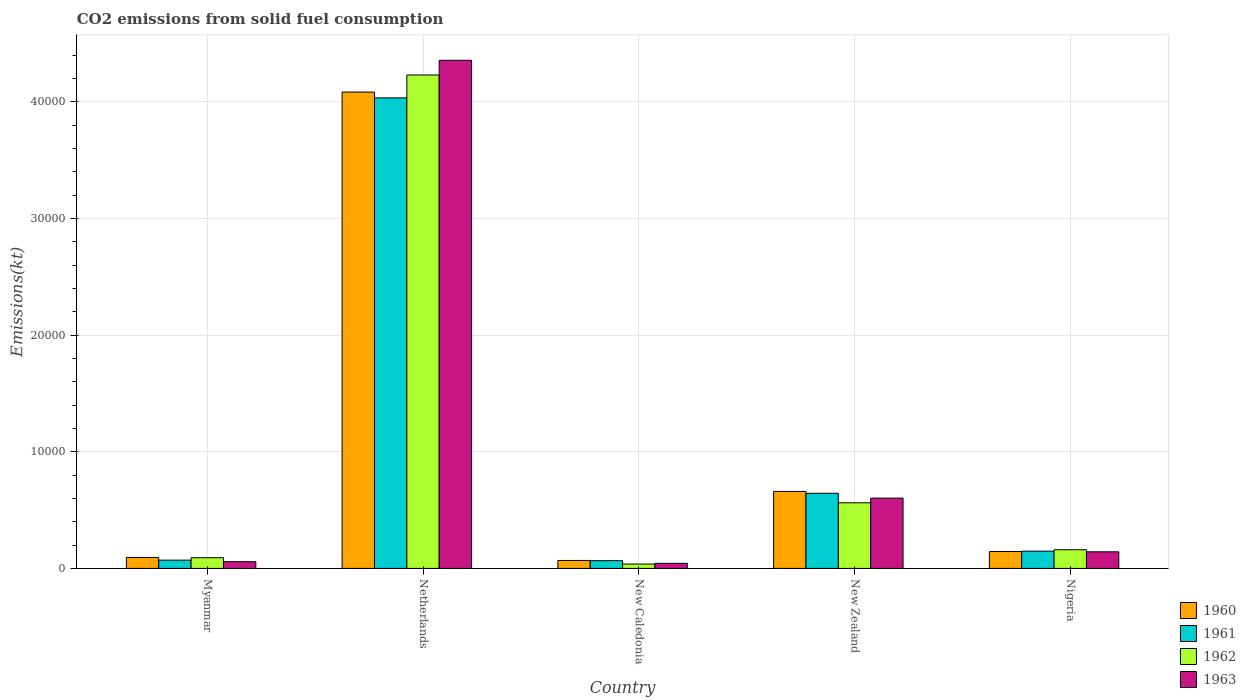How many bars are there on the 1st tick from the left?
Provide a short and direct response. 4. How many bars are there on the 4th tick from the right?
Your answer should be very brief. 4. What is the label of the 5th group of bars from the left?
Provide a short and direct response. Nigeria. In how many cases, is the number of bars for a given country not equal to the number of legend labels?
Offer a very short reply. 0. What is the amount of CO2 emitted in 1963 in Nigeria?
Give a very brief answer. 1422.8. Across all countries, what is the maximum amount of CO2 emitted in 1961?
Ensure brevity in your answer.  4.03e+04. Across all countries, what is the minimum amount of CO2 emitted in 1960?
Offer a very short reply. 682.06. In which country was the amount of CO2 emitted in 1962 maximum?
Provide a succinct answer. Netherlands. In which country was the amount of CO2 emitted in 1962 minimum?
Provide a succinct answer. New Caledonia. What is the total amount of CO2 emitted in 1960 in the graph?
Offer a terse response. 5.05e+04. What is the difference between the amount of CO2 emitted in 1962 in Myanmar and that in Nigeria?
Your answer should be compact. -682.06. What is the difference between the amount of CO2 emitted in 1960 in Netherlands and the amount of CO2 emitted in 1961 in Myanmar?
Your answer should be compact. 4.01e+04. What is the average amount of CO2 emitted in 1963 per country?
Offer a very short reply. 1.04e+04. What is the difference between the amount of CO2 emitted of/in 1960 and amount of CO2 emitted of/in 1963 in Myanmar?
Your answer should be compact. 363.03. In how many countries, is the amount of CO2 emitted in 1960 greater than 28000 kt?
Your answer should be very brief. 1. What is the ratio of the amount of CO2 emitted in 1962 in New Caledonia to that in New Zealand?
Give a very brief answer. 0.07. What is the difference between the highest and the second highest amount of CO2 emitted in 1961?
Give a very brief answer. -3.89e+04. What is the difference between the highest and the lowest amount of CO2 emitted in 1962?
Offer a very short reply. 4.19e+04. Is the sum of the amount of CO2 emitted in 1963 in Myanmar and Netherlands greater than the maximum amount of CO2 emitted in 1962 across all countries?
Offer a terse response. Yes. What does the 1st bar from the left in Netherlands represents?
Offer a terse response. 1960. How many countries are there in the graph?
Give a very brief answer. 5. What is the difference between two consecutive major ticks on the Y-axis?
Your response must be concise. 10000. Does the graph contain any zero values?
Offer a very short reply. No. Does the graph contain grids?
Ensure brevity in your answer.  Yes. Where does the legend appear in the graph?
Keep it short and to the point. Bottom right. How are the legend labels stacked?
Your response must be concise. Vertical. What is the title of the graph?
Provide a succinct answer. CO2 emissions from solid fuel consumption. What is the label or title of the Y-axis?
Give a very brief answer. Emissions(kt). What is the Emissions(kt) of 1960 in Myanmar?
Keep it short and to the point. 938.75. What is the Emissions(kt) of 1961 in Myanmar?
Provide a short and direct response. 707.73. What is the Emissions(kt) of 1962 in Myanmar?
Keep it short and to the point. 916.75. What is the Emissions(kt) in 1963 in Myanmar?
Provide a short and direct response. 575.72. What is the Emissions(kt) in 1960 in Netherlands?
Offer a terse response. 4.08e+04. What is the Emissions(kt) of 1961 in Netherlands?
Offer a very short reply. 4.03e+04. What is the Emissions(kt) of 1962 in Netherlands?
Make the answer very short. 4.23e+04. What is the Emissions(kt) of 1963 in Netherlands?
Offer a terse response. 4.36e+04. What is the Emissions(kt) of 1960 in New Caledonia?
Your answer should be very brief. 682.06. What is the Emissions(kt) of 1961 in New Caledonia?
Offer a very short reply. 663.73. What is the Emissions(kt) in 1962 in New Caledonia?
Make the answer very short. 374.03. What is the Emissions(kt) in 1963 in New Caledonia?
Offer a terse response. 436.37. What is the Emissions(kt) in 1960 in New Zealand?
Offer a terse response. 6600.6. What is the Emissions(kt) of 1961 in New Zealand?
Make the answer very short. 6439.25. What is the Emissions(kt) in 1962 in New Zealand?
Your answer should be compact. 5625.18. What is the Emissions(kt) in 1963 in New Zealand?
Make the answer very short. 6024.88. What is the Emissions(kt) in 1960 in Nigeria?
Make the answer very short. 1448.46. What is the Emissions(kt) in 1961 in Nigeria?
Offer a terse response. 1477.8. What is the Emissions(kt) in 1962 in Nigeria?
Your answer should be very brief. 1598.81. What is the Emissions(kt) of 1963 in Nigeria?
Provide a succinct answer. 1422.8. Across all countries, what is the maximum Emissions(kt) in 1960?
Give a very brief answer. 4.08e+04. Across all countries, what is the maximum Emissions(kt) of 1961?
Keep it short and to the point. 4.03e+04. Across all countries, what is the maximum Emissions(kt) in 1962?
Your response must be concise. 4.23e+04. Across all countries, what is the maximum Emissions(kt) of 1963?
Offer a terse response. 4.36e+04. Across all countries, what is the minimum Emissions(kt) in 1960?
Give a very brief answer. 682.06. Across all countries, what is the minimum Emissions(kt) in 1961?
Your answer should be very brief. 663.73. Across all countries, what is the minimum Emissions(kt) of 1962?
Your answer should be very brief. 374.03. Across all countries, what is the minimum Emissions(kt) of 1963?
Give a very brief answer. 436.37. What is the total Emissions(kt) of 1960 in the graph?
Keep it short and to the point. 5.05e+04. What is the total Emissions(kt) of 1961 in the graph?
Your answer should be compact. 4.96e+04. What is the total Emissions(kt) in 1962 in the graph?
Provide a succinct answer. 5.08e+04. What is the total Emissions(kt) in 1963 in the graph?
Provide a succinct answer. 5.20e+04. What is the difference between the Emissions(kt) in 1960 in Myanmar and that in Netherlands?
Give a very brief answer. -3.99e+04. What is the difference between the Emissions(kt) in 1961 in Myanmar and that in Netherlands?
Provide a succinct answer. -3.96e+04. What is the difference between the Emissions(kt) of 1962 in Myanmar and that in Netherlands?
Provide a short and direct response. -4.14e+04. What is the difference between the Emissions(kt) in 1963 in Myanmar and that in Netherlands?
Offer a very short reply. -4.30e+04. What is the difference between the Emissions(kt) in 1960 in Myanmar and that in New Caledonia?
Make the answer very short. 256.69. What is the difference between the Emissions(kt) in 1961 in Myanmar and that in New Caledonia?
Ensure brevity in your answer.  44. What is the difference between the Emissions(kt) of 1962 in Myanmar and that in New Caledonia?
Offer a very short reply. 542.72. What is the difference between the Emissions(kt) in 1963 in Myanmar and that in New Caledonia?
Provide a succinct answer. 139.35. What is the difference between the Emissions(kt) in 1960 in Myanmar and that in New Zealand?
Provide a short and direct response. -5661.85. What is the difference between the Emissions(kt) of 1961 in Myanmar and that in New Zealand?
Keep it short and to the point. -5731.52. What is the difference between the Emissions(kt) in 1962 in Myanmar and that in New Zealand?
Provide a short and direct response. -4708.43. What is the difference between the Emissions(kt) of 1963 in Myanmar and that in New Zealand?
Make the answer very short. -5449.16. What is the difference between the Emissions(kt) of 1960 in Myanmar and that in Nigeria?
Your answer should be compact. -509.71. What is the difference between the Emissions(kt) in 1961 in Myanmar and that in Nigeria?
Your answer should be compact. -770.07. What is the difference between the Emissions(kt) of 1962 in Myanmar and that in Nigeria?
Make the answer very short. -682.06. What is the difference between the Emissions(kt) in 1963 in Myanmar and that in Nigeria?
Provide a succinct answer. -847.08. What is the difference between the Emissions(kt) in 1960 in Netherlands and that in New Caledonia?
Offer a very short reply. 4.01e+04. What is the difference between the Emissions(kt) of 1961 in Netherlands and that in New Caledonia?
Give a very brief answer. 3.97e+04. What is the difference between the Emissions(kt) in 1962 in Netherlands and that in New Caledonia?
Offer a very short reply. 4.19e+04. What is the difference between the Emissions(kt) in 1963 in Netherlands and that in New Caledonia?
Provide a short and direct response. 4.31e+04. What is the difference between the Emissions(kt) in 1960 in Netherlands and that in New Zealand?
Keep it short and to the point. 3.42e+04. What is the difference between the Emissions(kt) of 1961 in Netherlands and that in New Zealand?
Your answer should be very brief. 3.39e+04. What is the difference between the Emissions(kt) of 1962 in Netherlands and that in New Zealand?
Offer a very short reply. 3.67e+04. What is the difference between the Emissions(kt) in 1963 in Netherlands and that in New Zealand?
Offer a terse response. 3.75e+04. What is the difference between the Emissions(kt) of 1960 in Netherlands and that in Nigeria?
Make the answer very short. 3.94e+04. What is the difference between the Emissions(kt) in 1961 in Netherlands and that in Nigeria?
Offer a terse response. 3.89e+04. What is the difference between the Emissions(kt) in 1962 in Netherlands and that in Nigeria?
Give a very brief answer. 4.07e+04. What is the difference between the Emissions(kt) of 1963 in Netherlands and that in Nigeria?
Keep it short and to the point. 4.21e+04. What is the difference between the Emissions(kt) in 1960 in New Caledonia and that in New Zealand?
Keep it short and to the point. -5918.54. What is the difference between the Emissions(kt) of 1961 in New Caledonia and that in New Zealand?
Offer a terse response. -5775.52. What is the difference between the Emissions(kt) in 1962 in New Caledonia and that in New Zealand?
Your answer should be very brief. -5251.14. What is the difference between the Emissions(kt) of 1963 in New Caledonia and that in New Zealand?
Make the answer very short. -5588.51. What is the difference between the Emissions(kt) in 1960 in New Caledonia and that in Nigeria?
Your answer should be compact. -766.4. What is the difference between the Emissions(kt) of 1961 in New Caledonia and that in Nigeria?
Ensure brevity in your answer.  -814.07. What is the difference between the Emissions(kt) of 1962 in New Caledonia and that in Nigeria?
Provide a succinct answer. -1224.78. What is the difference between the Emissions(kt) in 1963 in New Caledonia and that in Nigeria?
Keep it short and to the point. -986.42. What is the difference between the Emissions(kt) in 1960 in New Zealand and that in Nigeria?
Provide a succinct answer. 5152.14. What is the difference between the Emissions(kt) of 1961 in New Zealand and that in Nigeria?
Your answer should be very brief. 4961.45. What is the difference between the Emissions(kt) of 1962 in New Zealand and that in Nigeria?
Your response must be concise. 4026.37. What is the difference between the Emissions(kt) of 1963 in New Zealand and that in Nigeria?
Your answer should be compact. 4602.09. What is the difference between the Emissions(kt) in 1960 in Myanmar and the Emissions(kt) in 1961 in Netherlands?
Your response must be concise. -3.94e+04. What is the difference between the Emissions(kt) of 1960 in Myanmar and the Emissions(kt) of 1962 in Netherlands?
Your response must be concise. -4.14e+04. What is the difference between the Emissions(kt) in 1960 in Myanmar and the Emissions(kt) in 1963 in Netherlands?
Your answer should be very brief. -4.26e+04. What is the difference between the Emissions(kt) of 1961 in Myanmar and the Emissions(kt) of 1962 in Netherlands?
Your response must be concise. -4.16e+04. What is the difference between the Emissions(kt) of 1961 in Myanmar and the Emissions(kt) of 1963 in Netherlands?
Give a very brief answer. -4.28e+04. What is the difference between the Emissions(kt) in 1962 in Myanmar and the Emissions(kt) in 1963 in Netherlands?
Keep it short and to the point. -4.26e+04. What is the difference between the Emissions(kt) in 1960 in Myanmar and the Emissions(kt) in 1961 in New Caledonia?
Your answer should be very brief. 275.02. What is the difference between the Emissions(kt) in 1960 in Myanmar and the Emissions(kt) in 1962 in New Caledonia?
Provide a succinct answer. 564.72. What is the difference between the Emissions(kt) in 1960 in Myanmar and the Emissions(kt) in 1963 in New Caledonia?
Your answer should be compact. 502.38. What is the difference between the Emissions(kt) in 1961 in Myanmar and the Emissions(kt) in 1962 in New Caledonia?
Offer a terse response. 333.7. What is the difference between the Emissions(kt) in 1961 in Myanmar and the Emissions(kt) in 1963 in New Caledonia?
Give a very brief answer. 271.36. What is the difference between the Emissions(kt) in 1962 in Myanmar and the Emissions(kt) in 1963 in New Caledonia?
Provide a short and direct response. 480.38. What is the difference between the Emissions(kt) of 1960 in Myanmar and the Emissions(kt) of 1961 in New Zealand?
Give a very brief answer. -5500.5. What is the difference between the Emissions(kt) in 1960 in Myanmar and the Emissions(kt) in 1962 in New Zealand?
Offer a very short reply. -4686.43. What is the difference between the Emissions(kt) of 1960 in Myanmar and the Emissions(kt) of 1963 in New Zealand?
Make the answer very short. -5086.13. What is the difference between the Emissions(kt) of 1961 in Myanmar and the Emissions(kt) of 1962 in New Zealand?
Keep it short and to the point. -4917.45. What is the difference between the Emissions(kt) of 1961 in Myanmar and the Emissions(kt) of 1963 in New Zealand?
Make the answer very short. -5317.15. What is the difference between the Emissions(kt) of 1962 in Myanmar and the Emissions(kt) of 1963 in New Zealand?
Ensure brevity in your answer.  -5108.13. What is the difference between the Emissions(kt) of 1960 in Myanmar and the Emissions(kt) of 1961 in Nigeria?
Offer a very short reply. -539.05. What is the difference between the Emissions(kt) of 1960 in Myanmar and the Emissions(kt) of 1962 in Nigeria?
Offer a terse response. -660.06. What is the difference between the Emissions(kt) of 1960 in Myanmar and the Emissions(kt) of 1963 in Nigeria?
Your response must be concise. -484.04. What is the difference between the Emissions(kt) of 1961 in Myanmar and the Emissions(kt) of 1962 in Nigeria?
Your response must be concise. -891.08. What is the difference between the Emissions(kt) in 1961 in Myanmar and the Emissions(kt) in 1963 in Nigeria?
Ensure brevity in your answer.  -715.07. What is the difference between the Emissions(kt) in 1962 in Myanmar and the Emissions(kt) in 1963 in Nigeria?
Your answer should be very brief. -506.05. What is the difference between the Emissions(kt) of 1960 in Netherlands and the Emissions(kt) of 1961 in New Caledonia?
Your response must be concise. 4.02e+04. What is the difference between the Emissions(kt) of 1960 in Netherlands and the Emissions(kt) of 1962 in New Caledonia?
Keep it short and to the point. 4.05e+04. What is the difference between the Emissions(kt) of 1960 in Netherlands and the Emissions(kt) of 1963 in New Caledonia?
Give a very brief answer. 4.04e+04. What is the difference between the Emissions(kt) in 1961 in Netherlands and the Emissions(kt) in 1962 in New Caledonia?
Provide a succinct answer. 4.00e+04. What is the difference between the Emissions(kt) of 1961 in Netherlands and the Emissions(kt) of 1963 in New Caledonia?
Keep it short and to the point. 3.99e+04. What is the difference between the Emissions(kt) of 1962 in Netherlands and the Emissions(kt) of 1963 in New Caledonia?
Your answer should be very brief. 4.19e+04. What is the difference between the Emissions(kt) of 1960 in Netherlands and the Emissions(kt) of 1961 in New Zealand?
Give a very brief answer. 3.44e+04. What is the difference between the Emissions(kt) in 1960 in Netherlands and the Emissions(kt) in 1962 in New Zealand?
Your response must be concise. 3.52e+04. What is the difference between the Emissions(kt) of 1960 in Netherlands and the Emissions(kt) of 1963 in New Zealand?
Ensure brevity in your answer.  3.48e+04. What is the difference between the Emissions(kt) of 1961 in Netherlands and the Emissions(kt) of 1962 in New Zealand?
Your response must be concise. 3.47e+04. What is the difference between the Emissions(kt) of 1961 in Netherlands and the Emissions(kt) of 1963 in New Zealand?
Make the answer very short. 3.43e+04. What is the difference between the Emissions(kt) in 1962 in Netherlands and the Emissions(kt) in 1963 in New Zealand?
Give a very brief answer. 3.63e+04. What is the difference between the Emissions(kt) of 1960 in Netherlands and the Emissions(kt) of 1961 in Nigeria?
Give a very brief answer. 3.94e+04. What is the difference between the Emissions(kt) in 1960 in Netherlands and the Emissions(kt) in 1962 in Nigeria?
Provide a short and direct response. 3.92e+04. What is the difference between the Emissions(kt) in 1960 in Netherlands and the Emissions(kt) in 1963 in Nigeria?
Your answer should be very brief. 3.94e+04. What is the difference between the Emissions(kt) of 1961 in Netherlands and the Emissions(kt) of 1962 in Nigeria?
Your response must be concise. 3.87e+04. What is the difference between the Emissions(kt) of 1961 in Netherlands and the Emissions(kt) of 1963 in Nigeria?
Your answer should be very brief. 3.89e+04. What is the difference between the Emissions(kt) in 1962 in Netherlands and the Emissions(kt) in 1963 in Nigeria?
Keep it short and to the point. 4.09e+04. What is the difference between the Emissions(kt) of 1960 in New Caledonia and the Emissions(kt) of 1961 in New Zealand?
Provide a short and direct response. -5757.19. What is the difference between the Emissions(kt) of 1960 in New Caledonia and the Emissions(kt) of 1962 in New Zealand?
Offer a very short reply. -4943.12. What is the difference between the Emissions(kt) in 1960 in New Caledonia and the Emissions(kt) in 1963 in New Zealand?
Your answer should be very brief. -5342.82. What is the difference between the Emissions(kt) of 1961 in New Caledonia and the Emissions(kt) of 1962 in New Zealand?
Your answer should be compact. -4961.45. What is the difference between the Emissions(kt) of 1961 in New Caledonia and the Emissions(kt) of 1963 in New Zealand?
Your answer should be very brief. -5361.15. What is the difference between the Emissions(kt) in 1962 in New Caledonia and the Emissions(kt) in 1963 in New Zealand?
Your answer should be compact. -5650.85. What is the difference between the Emissions(kt) in 1960 in New Caledonia and the Emissions(kt) in 1961 in Nigeria?
Your answer should be very brief. -795.74. What is the difference between the Emissions(kt) in 1960 in New Caledonia and the Emissions(kt) in 1962 in Nigeria?
Give a very brief answer. -916.75. What is the difference between the Emissions(kt) of 1960 in New Caledonia and the Emissions(kt) of 1963 in Nigeria?
Ensure brevity in your answer.  -740.73. What is the difference between the Emissions(kt) of 1961 in New Caledonia and the Emissions(kt) of 1962 in Nigeria?
Your answer should be very brief. -935.09. What is the difference between the Emissions(kt) in 1961 in New Caledonia and the Emissions(kt) in 1963 in Nigeria?
Your answer should be very brief. -759.07. What is the difference between the Emissions(kt) in 1962 in New Caledonia and the Emissions(kt) in 1963 in Nigeria?
Your response must be concise. -1048.76. What is the difference between the Emissions(kt) of 1960 in New Zealand and the Emissions(kt) of 1961 in Nigeria?
Provide a succinct answer. 5122.8. What is the difference between the Emissions(kt) of 1960 in New Zealand and the Emissions(kt) of 1962 in Nigeria?
Your answer should be very brief. 5001.79. What is the difference between the Emissions(kt) in 1960 in New Zealand and the Emissions(kt) in 1963 in Nigeria?
Keep it short and to the point. 5177.8. What is the difference between the Emissions(kt) in 1961 in New Zealand and the Emissions(kt) in 1962 in Nigeria?
Provide a short and direct response. 4840.44. What is the difference between the Emissions(kt) of 1961 in New Zealand and the Emissions(kt) of 1963 in Nigeria?
Make the answer very short. 5016.46. What is the difference between the Emissions(kt) of 1962 in New Zealand and the Emissions(kt) of 1963 in Nigeria?
Your response must be concise. 4202.38. What is the average Emissions(kt) in 1960 per country?
Provide a short and direct response. 1.01e+04. What is the average Emissions(kt) of 1961 per country?
Offer a terse response. 9924.37. What is the average Emissions(kt) in 1962 per country?
Keep it short and to the point. 1.02e+04. What is the average Emissions(kt) of 1963 per country?
Give a very brief answer. 1.04e+04. What is the difference between the Emissions(kt) in 1960 and Emissions(kt) in 1961 in Myanmar?
Give a very brief answer. 231.02. What is the difference between the Emissions(kt) in 1960 and Emissions(kt) in 1962 in Myanmar?
Offer a very short reply. 22. What is the difference between the Emissions(kt) of 1960 and Emissions(kt) of 1963 in Myanmar?
Make the answer very short. 363.03. What is the difference between the Emissions(kt) of 1961 and Emissions(kt) of 1962 in Myanmar?
Your answer should be very brief. -209.02. What is the difference between the Emissions(kt) of 1961 and Emissions(kt) of 1963 in Myanmar?
Your answer should be compact. 132.01. What is the difference between the Emissions(kt) in 1962 and Emissions(kt) in 1963 in Myanmar?
Offer a terse response. 341.03. What is the difference between the Emissions(kt) in 1960 and Emissions(kt) in 1961 in Netherlands?
Ensure brevity in your answer.  498.71. What is the difference between the Emissions(kt) in 1960 and Emissions(kt) in 1962 in Netherlands?
Your response must be concise. -1463.13. What is the difference between the Emissions(kt) in 1960 and Emissions(kt) in 1963 in Netherlands?
Provide a succinct answer. -2724.58. What is the difference between the Emissions(kt) of 1961 and Emissions(kt) of 1962 in Netherlands?
Give a very brief answer. -1961.85. What is the difference between the Emissions(kt) in 1961 and Emissions(kt) in 1963 in Netherlands?
Ensure brevity in your answer.  -3223.29. What is the difference between the Emissions(kt) in 1962 and Emissions(kt) in 1963 in Netherlands?
Give a very brief answer. -1261.45. What is the difference between the Emissions(kt) in 1960 and Emissions(kt) in 1961 in New Caledonia?
Offer a terse response. 18.34. What is the difference between the Emissions(kt) in 1960 and Emissions(kt) in 1962 in New Caledonia?
Your response must be concise. 308.03. What is the difference between the Emissions(kt) in 1960 and Emissions(kt) in 1963 in New Caledonia?
Your answer should be very brief. 245.69. What is the difference between the Emissions(kt) in 1961 and Emissions(kt) in 1962 in New Caledonia?
Your answer should be compact. 289.69. What is the difference between the Emissions(kt) in 1961 and Emissions(kt) in 1963 in New Caledonia?
Provide a short and direct response. 227.35. What is the difference between the Emissions(kt) in 1962 and Emissions(kt) in 1963 in New Caledonia?
Offer a very short reply. -62.34. What is the difference between the Emissions(kt) of 1960 and Emissions(kt) of 1961 in New Zealand?
Provide a short and direct response. 161.35. What is the difference between the Emissions(kt) in 1960 and Emissions(kt) in 1962 in New Zealand?
Provide a short and direct response. 975.42. What is the difference between the Emissions(kt) in 1960 and Emissions(kt) in 1963 in New Zealand?
Provide a short and direct response. 575.72. What is the difference between the Emissions(kt) in 1961 and Emissions(kt) in 1962 in New Zealand?
Offer a very short reply. 814.07. What is the difference between the Emissions(kt) in 1961 and Emissions(kt) in 1963 in New Zealand?
Offer a terse response. 414.37. What is the difference between the Emissions(kt) in 1962 and Emissions(kt) in 1963 in New Zealand?
Offer a terse response. -399.7. What is the difference between the Emissions(kt) of 1960 and Emissions(kt) of 1961 in Nigeria?
Your answer should be compact. -29.34. What is the difference between the Emissions(kt) of 1960 and Emissions(kt) of 1962 in Nigeria?
Provide a succinct answer. -150.35. What is the difference between the Emissions(kt) of 1960 and Emissions(kt) of 1963 in Nigeria?
Provide a short and direct response. 25.67. What is the difference between the Emissions(kt) in 1961 and Emissions(kt) in 1962 in Nigeria?
Your answer should be compact. -121.01. What is the difference between the Emissions(kt) of 1961 and Emissions(kt) of 1963 in Nigeria?
Your answer should be very brief. 55.01. What is the difference between the Emissions(kt) in 1962 and Emissions(kt) in 1963 in Nigeria?
Offer a terse response. 176.02. What is the ratio of the Emissions(kt) of 1960 in Myanmar to that in Netherlands?
Provide a succinct answer. 0.02. What is the ratio of the Emissions(kt) of 1961 in Myanmar to that in Netherlands?
Your answer should be very brief. 0.02. What is the ratio of the Emissions(kt) of 1962 in Myanmar to that in Netherlands?
Provide a short and direct response. 0.02. What is the ratio of the Emissions(kt) of 1963 in Myanmar to that in Netherlands?
Give a very brief answer. 0.01. What is the ratio of the Emissions(kt) of 1960 in Myanmar to that in New Caledonia?
Provide a short and direct response. 1.38. What is the ratio of the Emissions(kt) of 1961 in Myanmar to that in New Caledonia?
Give a very brief answer. 1.07. What is the ratio of the Emissions(kt) of 1962 in Myanmar to that in New Caledonia?
Give a very brief answer. 2.45. What is the ratio of the Emissions(kt) of 1963 in Myanmar to that in New Caledonia?
Make the answer very short. 1.32. What is the ratio of the Emissions(kt) of 1960 in Myanmar to that in New Zealand?
Your answer should be compact. 0.14. What is the ratio of the Emissions(kt) in 1961 in Myanmar to that in New Zealand?
Your response must be concise. 0.11. What is the ratio of the Emissions(kt) of 1962 in Myanmar to that in New Zealand?
Make the answer very short. 0.16. What is the ratio of the Emissions(kt) in 1963 in Myanmar to that in New Zealand?
Make the answer very short. 0.1. What is the ratio of the Emissions(kt) in 1960 in Myanmar to that in Nigeria?
Offer a terse response. 0.65. What is the ratio of the Emissions(kt) of 1961 in Myanmar to that in Nigeria?
Ensure brevity in your answer.  0.48. What is the ratio of the Emissions(kt) in 1962 in Myanmar to that in Nigeria?
Give a very brief answer. 0.57. What is the ratio of the Emissions(kt) of 1963 in Myanmar to that in Nigeria?
Your answer should be compact. 0.4. What is the ratio of the Emissions(kt) of 1960 in Netherlands to that in New Caledonia?
Offer a terse response. 59.87. What is the ratio of the Emissions(kt) of 1961 in Netherlands to that in New Caledonia?
Your answer should be compact. 60.77. What is the ratio of the Emissions(kt) of 1962 in Netherlands to that in New Caledonia?
Provide a short and direct response. 113.08. What is the ratio of the Emissions(kt) of 1963 in Netherlands to that in New Caledonia?
Your response must be concise. 99.82. What is the ratio of the Emissions(kt) of 1960 in Netherlands to that in New Zealand?
Your response must be concise. 6.19. What is the ratio of the Emissions(kt) in 1961 in Netherlands to that in New Zealand?
Make the answer very short. 6.26. What is the ratio of the Emissions(kt) of 1962 in Netherlands to that in New Zealand?
Provide a succinct answer. 7.52. What is the ratio of the Emissions(kt) in 1963 in Netherlands to that in New Zealand?
Your answer should be very brief. 7.23. What is the ratio of the Emissions(kt) of 1960 in Netherlands to that in Nigeria?
Provide a short and direct response. 28.19. What is the ratio of the Emissions(kt) in 1961 in Netherlands to that in Nigeria?
Offer a terse response. 27.29. What is the ratio of the Emissions(kt) of 1962 in Netherlands to that in Nigeria?
Make the answer very short. 26.45. What is the ratio of the Emissions(kt) in 1963 in Netherlands to that in Nigeria?
Provide a short and direct response. 30.61. What is the ratio of the Emissions(kt) in 1960 in New Caledonia to that in New Zealand?
Offer a very short reply. 0.1. What is the ratio of the Emissions(kt) of 1961 in New Caledonia to that in New Zealand?
Make the answer very short. 0.1. What is the ratio of the Emissions(kt) in 1962 in New Caledonia to that in New Zealand?
Offer a very short reply. 0.07. What is the ratio of the Emissions(kt) in 1963 in New Caledonia to that in New Zealand?
Ensure brevity in your answer.  0.07. What is the ratio of the Emissions(kt) of 1960 in New Caledonia to that in Nigeria?
Keep it short and to the point. 0.47. What is the ratio of the Emissions(kt) in 1961 in New Caledonia to that in Nigeria?
Your answer should be compact. 0.45. What is the ratio of the Emissions(kt) in 1962 in New Caledonia to that in Nigeria?
Make the answer very short. 0.23. What is the ratio of the Emissions(kt) of 1963 in New Caledonia to that in Nigeria?
Give a very brief answer. 0.31. What is the ratio of the Emissions(kt) of 1960 in New Zealand to that in Nigeria?
Ensure brevity in your answer.  4.56. What is the ratio of the Emissions(kt) of 1961 in New Zealand to that in Nigeria?
Offer a very short reply. 4.36. What is the ratio of the Emissions(kt) in 1962 in New Zealand to that in Nigeria?
Keep it short and to the point. 3.52. What is the ratio of the Emissions(kt) of 1963 in New Zealand to that in Nigeria?
Ensure brevity in your answer.  4.23. What is the difference between the highest and the second highest Emissions(kt) in 1960?
Provide a succinct answer. 3.42e+04. What is the difference between the highest and the second highest Emissions(kt) of 1961?
Your answer should be compact. 3.39e+04. What is the difference between the highest and the second highest Emissions(kt) in 1962?
Ensure brevity in your answer.  3.67e+04. What is the difference between the highest and the second highest Emissions(kt) in 1963?
Offer a very short reply. 3.75e+04. What is the difference between the highest and the lowest Emissions(kt) of 1960?
Your answer should be compact. 4.01e+04. What is the difference between the highest and the lowest Emissions(kt) in 1961?
Provide a short and direct response. 3.97e+04. What is the difference between the highest and the lowest Emissions(kt) in 1962?
Make the answer very short. 4.19e+04. What is the difference between the highest and the lowest Emissions(kt) of 1963?
Keep it short and to the point. 4.31e+04. 